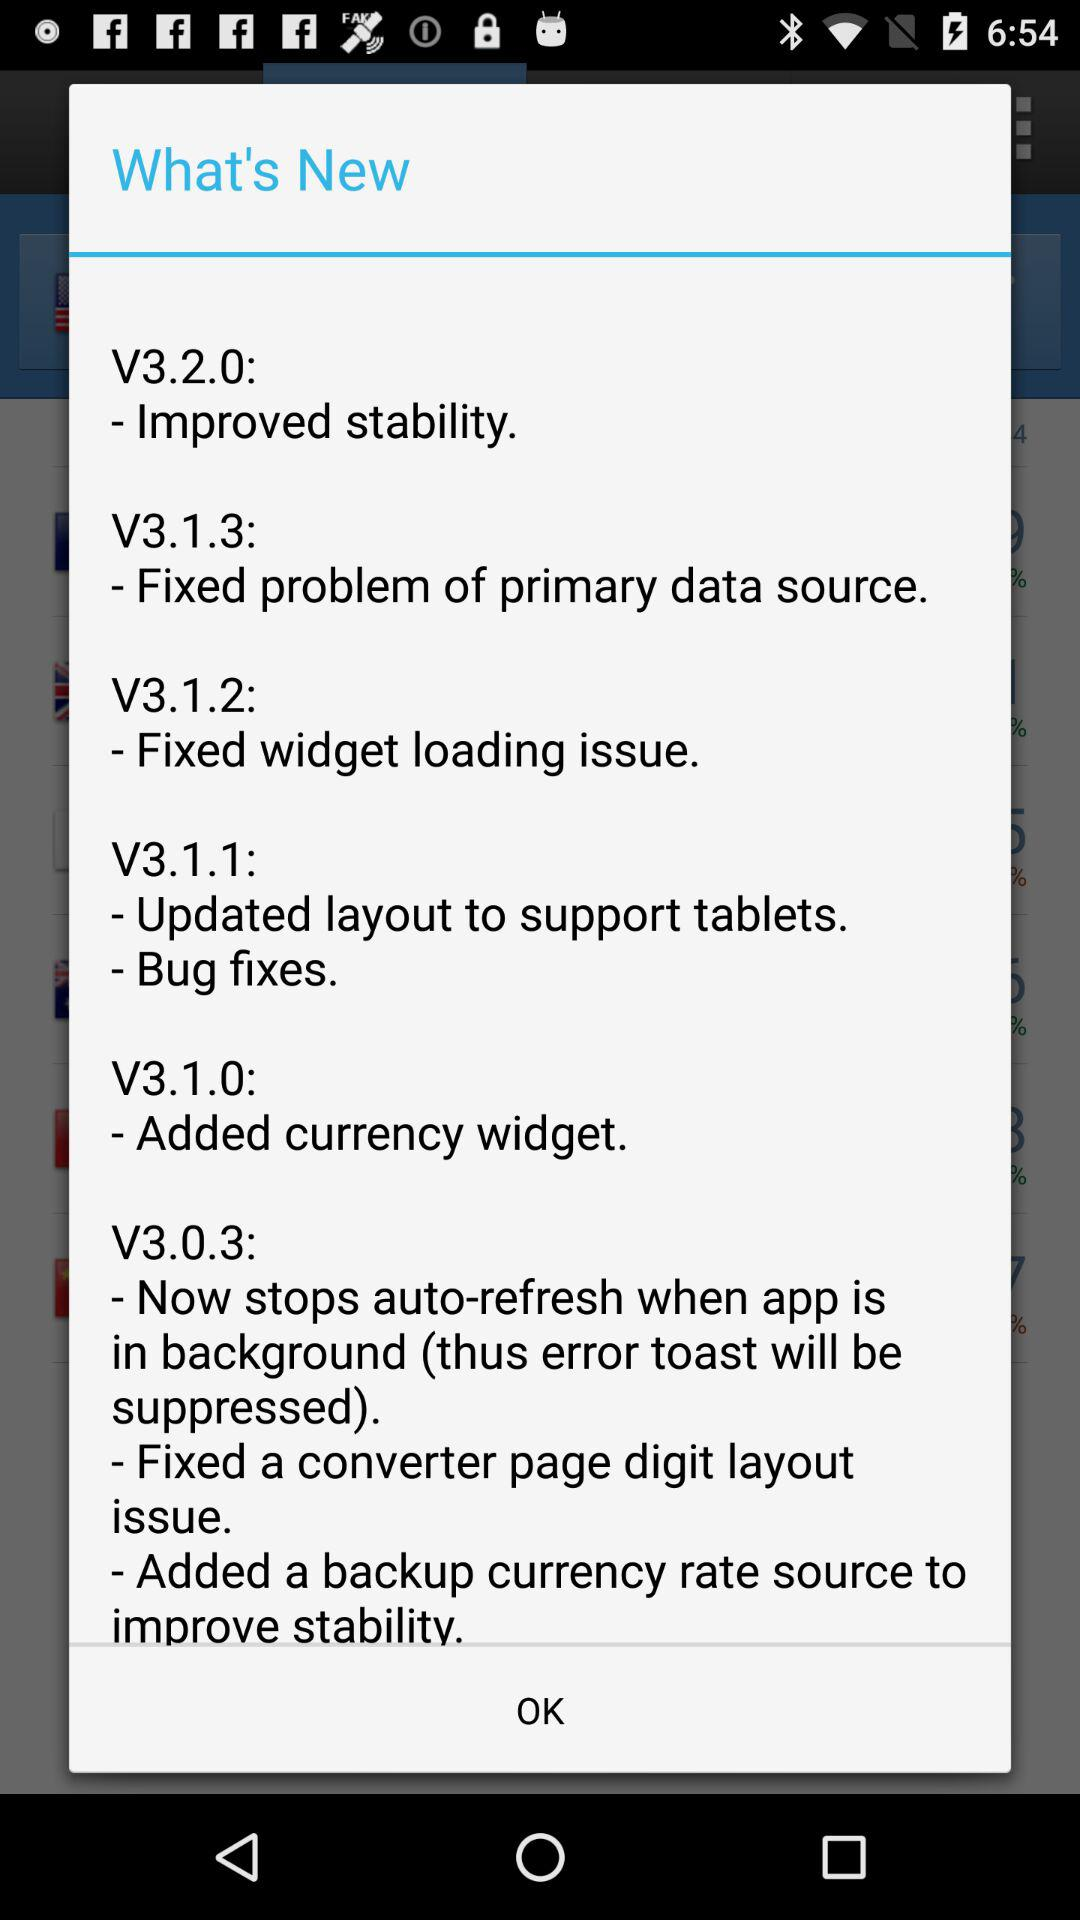What are the new features in V3.1.2? The new features in V3.1.2 is "Fixed widget loading issue". 